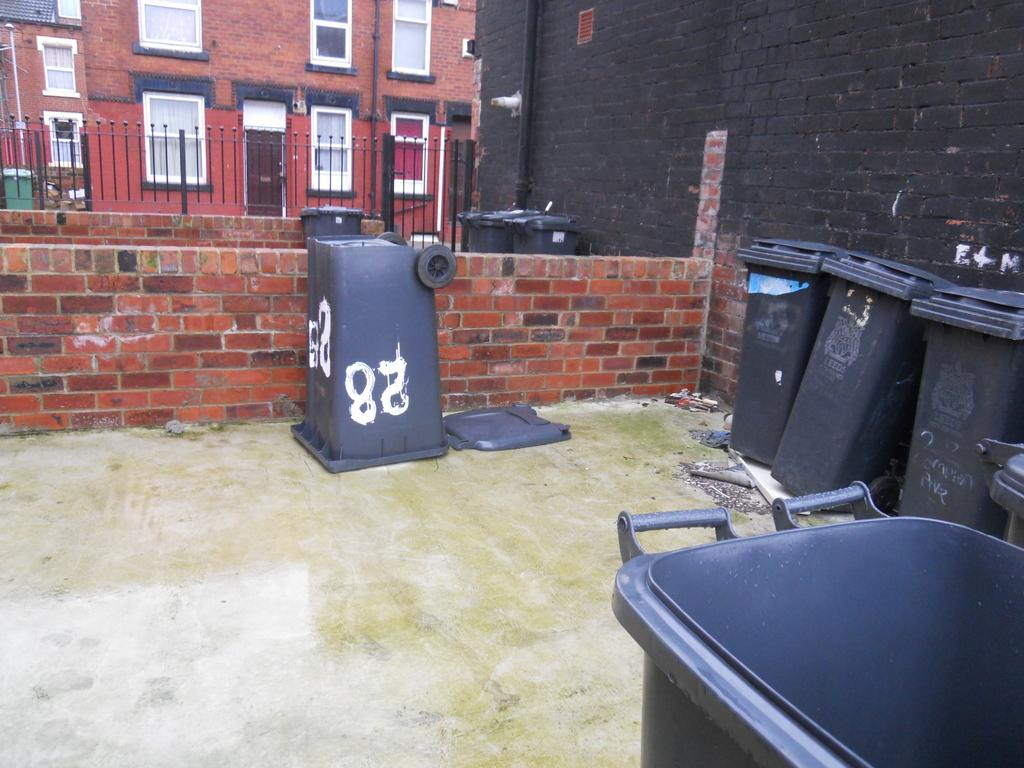Provide a one-sentence caption for the provided image. Garbage cans are placed in a courtyard type area with the number 28 painted on a garbage can that is upside down. 